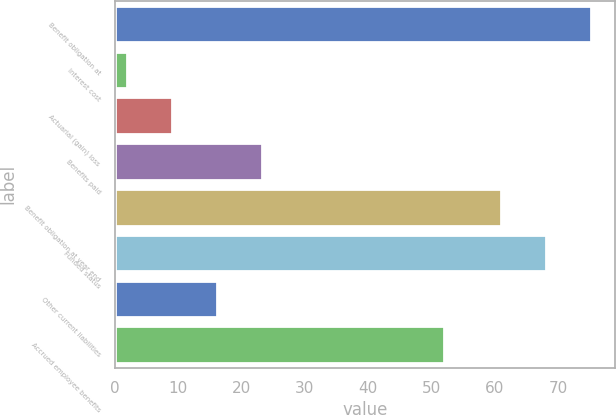Convert chart to OTSL. <chart><loc_0><loc_0><loc_500><loc_500><bar_chart><fcel>Benefit obligation at<fcel>Interest cost<fcel>Actuarial (gain) loss<fcel>Benefits paid<fcel>Benefit obligation at year end<fcel>Funded status<fcel>Other current liabilities<fcel>Accrued employee benefits<nl><fcel>75.2<fcel>2<fcel>9.1<fcel>23.3<fcel>61<fcel>68.1<fcel>16.2<fcel>52<nl></chart> 